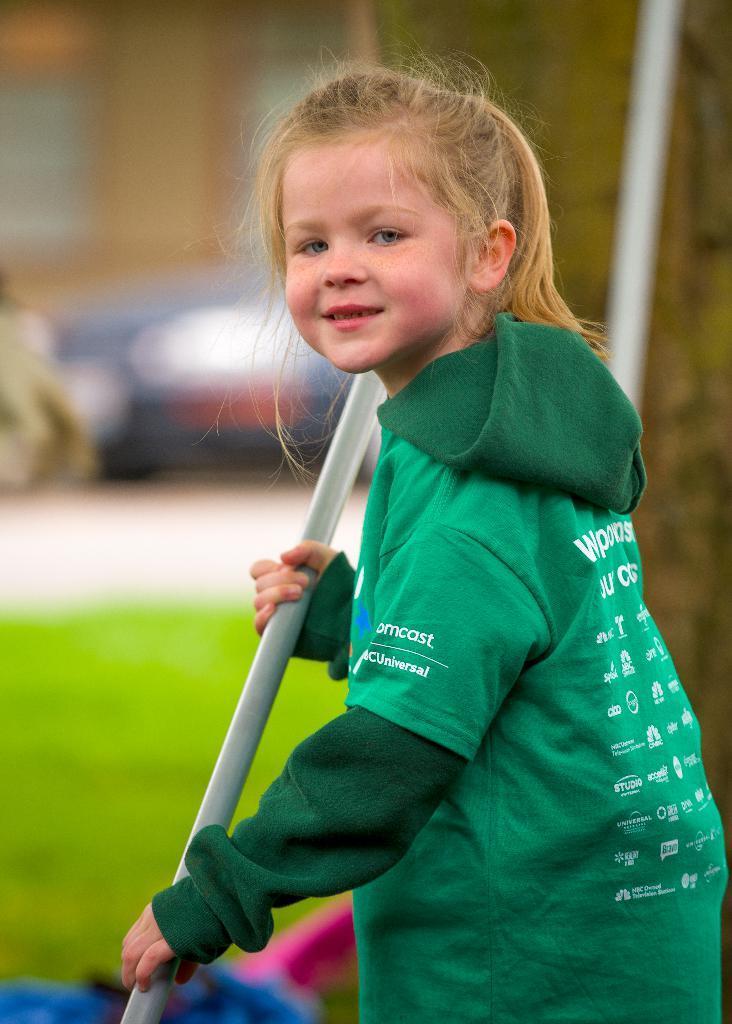Could you give a brief overview of what you see in this image? In this image I see a girl who is wearing green color hoodie and I see few words and logos on it and I see that she is holding a silver color rod. In the background it is blurred. 